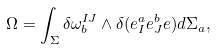Convert formula to latex. <formula><loc_0><loc_0><loc_500><loc_500>\Omega = \int _ { \Sigma } \delta \omega _ { b } ^ { I J } \wedge \delta ( e _ { I } ^ { a } e _ { J } ^ { b } e ) d \Sigma _ { a } ,</formula> 